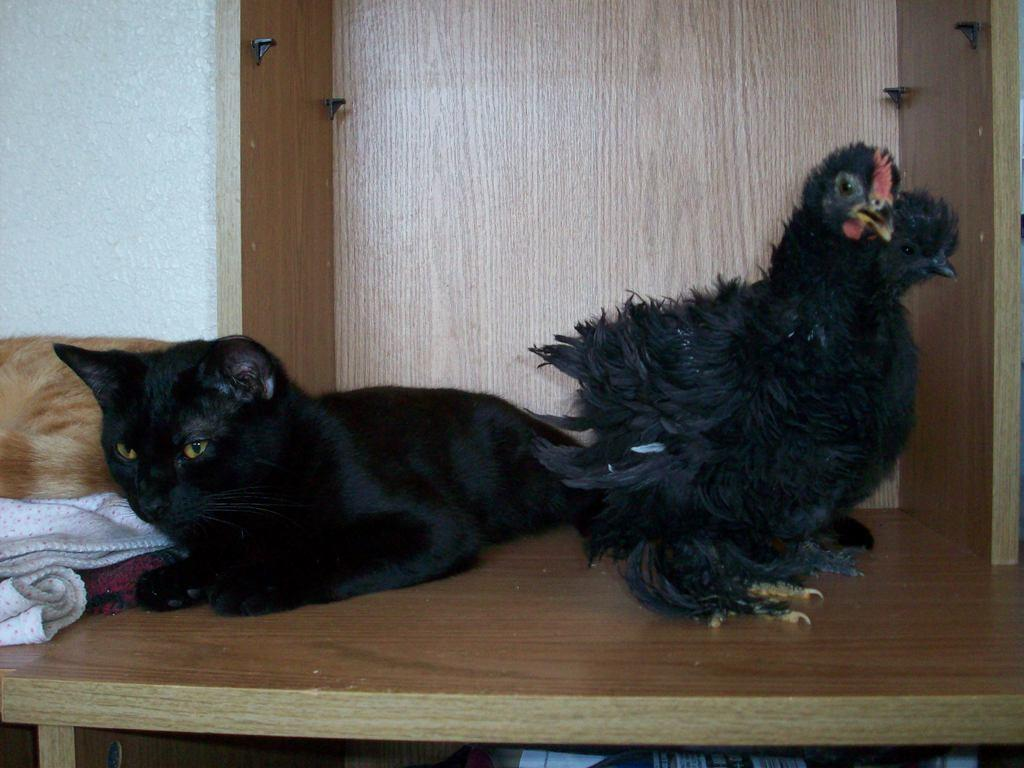What type of animal can be seen in the image? There is a dog in the image. Are there any other animals present in the image? Yes, there is a hen in the image. What is the surface that the dog and the hen are standing on? Both the dog and the hen are on a wooden surface. What message is conveyed by the sign in the image? There is no sign present in the image, so no message can be conveyed. 